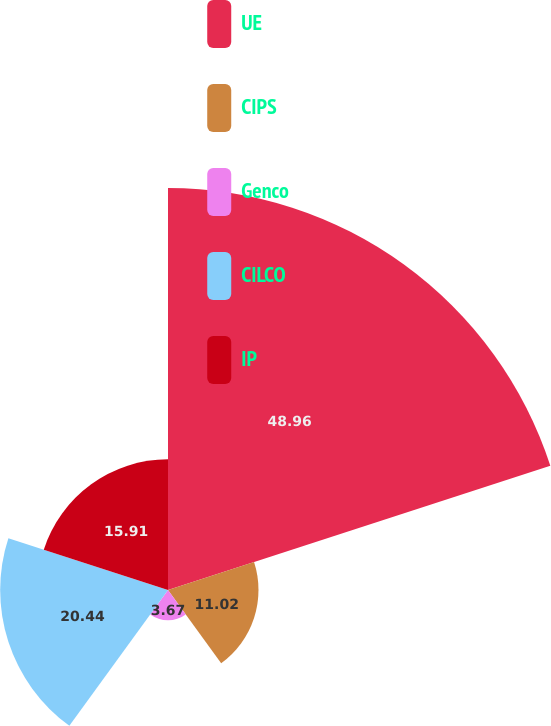Convert chart to OTSL. <chart><loc_0><loc_0><loc_500><loc_500><pie_chart><fcel>UE<fcel>CIPS<fcel>Genco<fcel>CILCO<fcel>IP<nl><fcel>48.96%<fcel>11.02%<fcel>3.67%<fcel>20.44%<fcel>15.91%<nl></chart> 